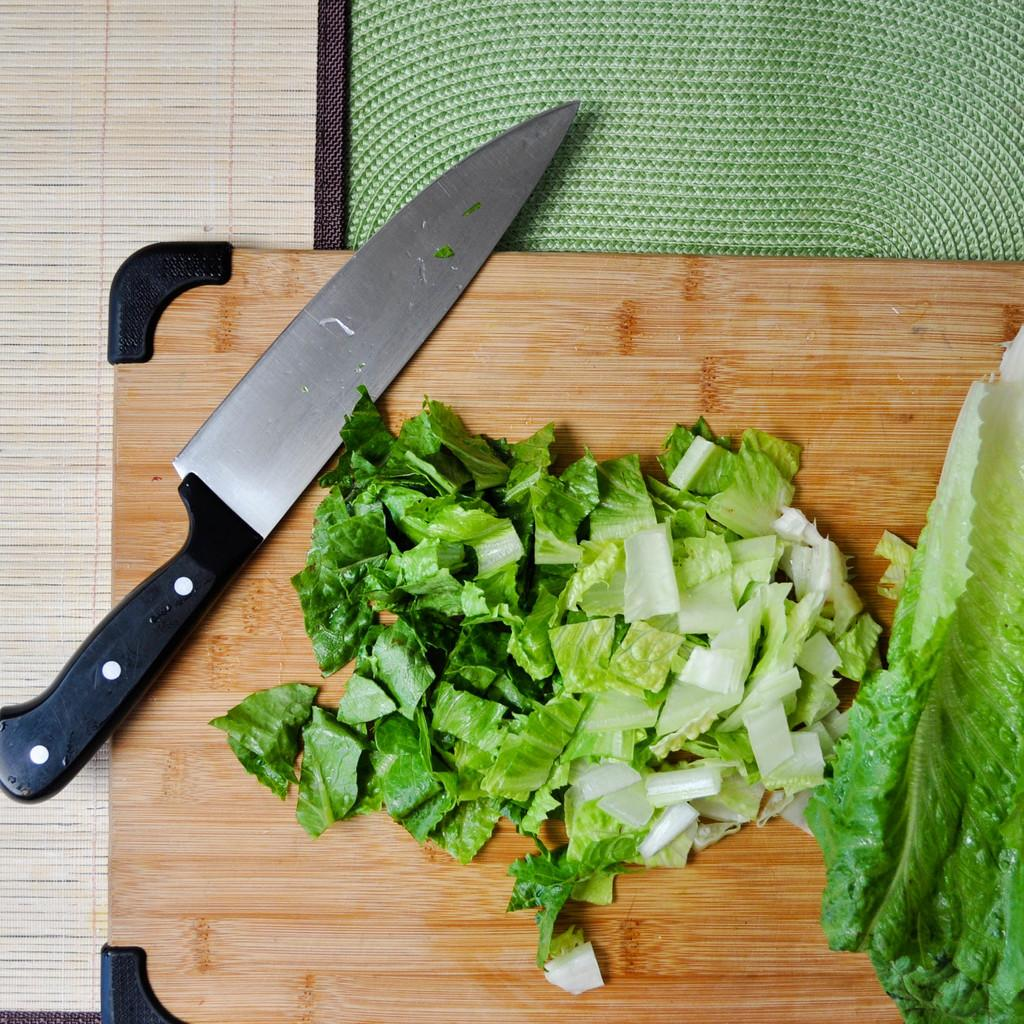What is on the cutting board in the image? A knife is placed on the cutting board in the image. What is the purpose of the knife on the cutting board? The knife is likely being used to cut the leaf into pieces, as seen in the image. What is the material of the mat at the top of the top of the image? The information provided does not specify the material of the mat, only that it is present in the image. What type of surface can be seen in the background of the image? There is a wooden surface visible in the background of the image. Can you tell me how many donkeys are present in the image? There are no donkeys present in the image; it features a cutting board, knife, leaf, mat, and wooden surface. What type of shock can be seen in the image? There is no shock present in the image; it is a still scene featuring a cutting board, knife, leaf, mat, and wooden surface. 